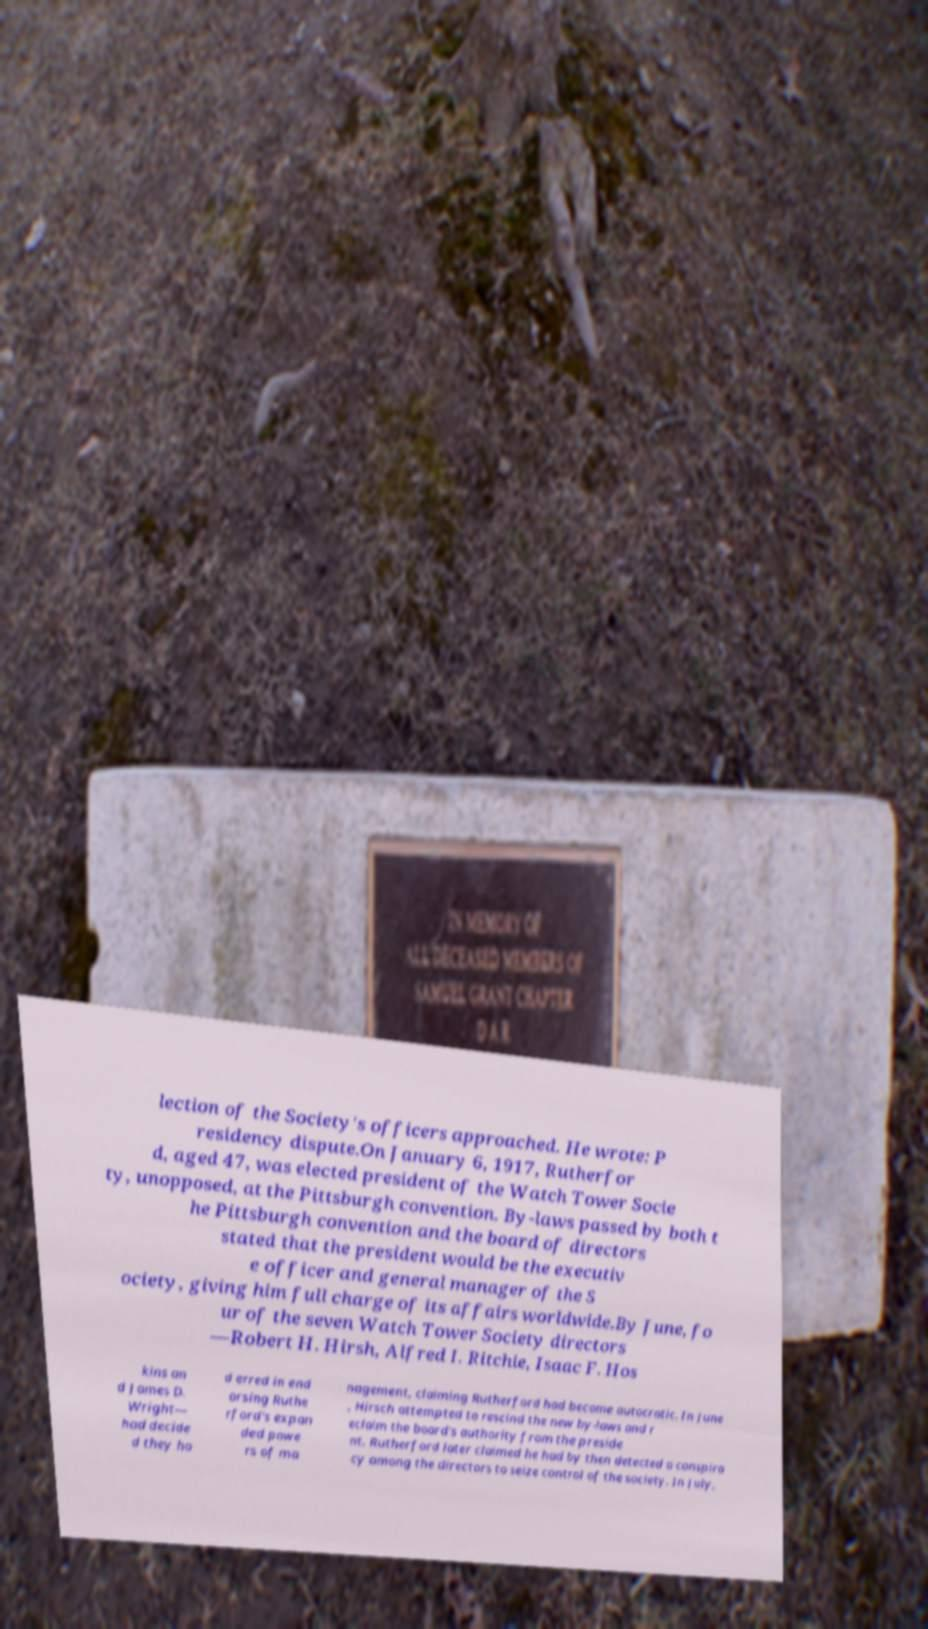Please identify and transcribe the text found in this image. lection of the Society's officers approached. He wrote: P residency dispute.On January 6, 1917, Rutherfor d, aged 47, was elected president of the Watch Tower Socie ty, unopposed, at the Pittsburgh convention. By-laws passed by both t he Pittsburgh convention and the board of directors stated that the president would be the executiv e officer and general manager of the S ociety, giving him full charge of its affairs worldwide.By June, fo ur of the seven Watch Tower Society directors —Robert H. Hirsh, Alfred I. Ritchie, Isaac F. Hos kins an d James D. Wright— had decide d they ha d erred in end orsing Ruthe rford's expan ded powe rs of ma nagement, claiming Rutherford had become autocratic. In June , Hirsch attempted to rescind the new by-laws and r eclaim the board's authority from the preside nt. Rutherford later claimed he had by then detected a conspira cy among the directors to seize control of the society. In July, 